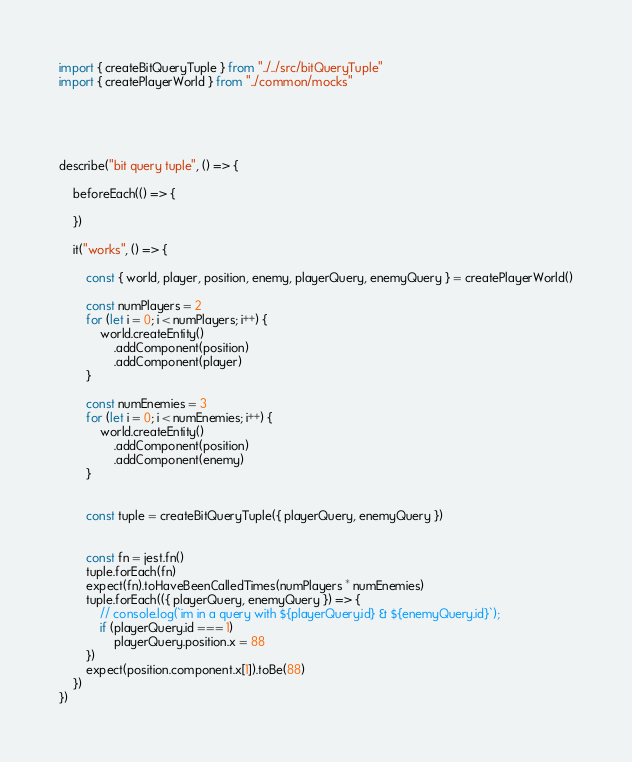Convert code to text. <code><loc_0><loc_0><loc_500><loc_500><_TypeScript_>import { createBitQueryTuple } from "../../src/bitQueryTuple"
import { createPlayerWorld } from "../common/mocks"





describe("bit query tuple", () => {

    beforeEach(() => {

    })

    it("works", () => {

        const { world, player, position, enemy, playerQuery, enemyQuery } = createPlayerWorld()

        const numPlayers = 2
        for (let i = 0; i < numPlayers; i++) {
            world.createEntity()
                .addComponent(position)
                .addComponent(player)
        }

        const numEnemies = 3
        for (let i = 0; i < numEnemies; i++) {
            world.createEntity()
                .addComponent(position)
                .addComponent(enemy)
        }


        const tuple = createBitQueryTuple({ playerQuery, enemyQuery })


        const fn = jest.fn()
        tuple.forEach(fn)
        expect(fn).toHaveBeenCalledTimes(numPlayers * numEnemies)
        tuple.forEach(({ playerQuery, enemyQuery }) => {
            // console.log(`im in a query with ${playerQuery.id} & ${enemyQuery.id}`);
            if (playerQuery.id === 1)
                playerQuery.position.x = 88
        })
        expect(position.component.x[1]).toBe(88)
    })
})</code> 